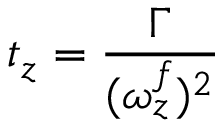Convert formula to latex. <formula><loc_0><loc_0><loc_500><loc_500>t _ { z } = \frac { \Gamma } { ( \omega _ { z } ^ { f } ) ^ { 2 } }</formula> 